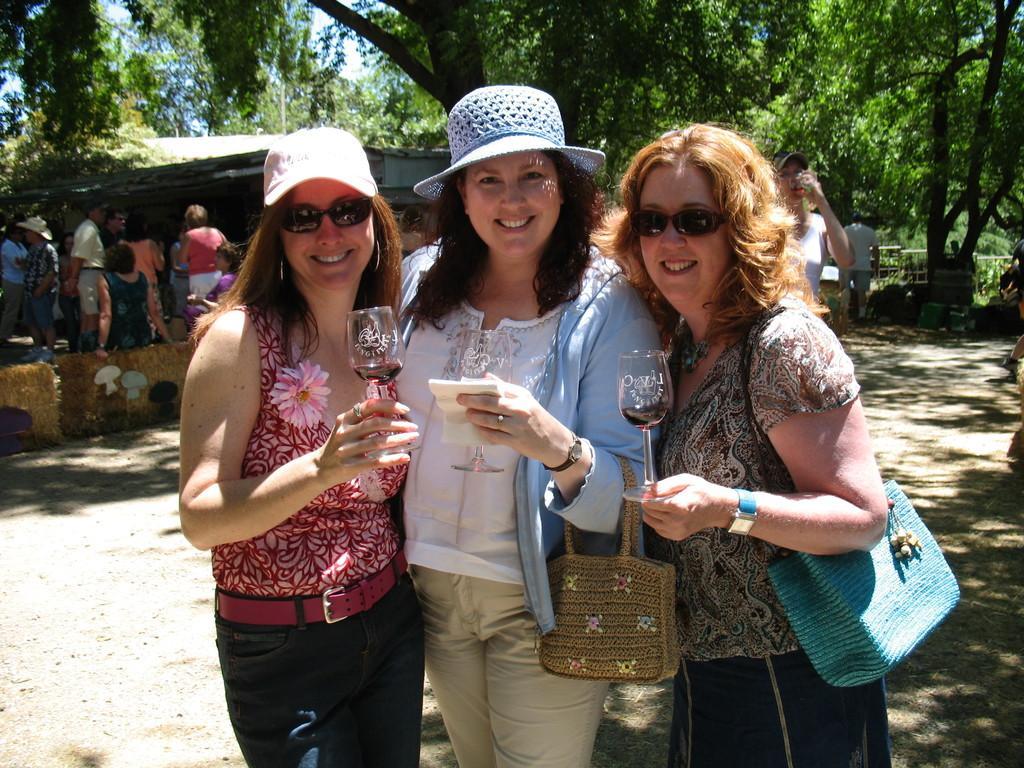Describe this image in one or two sentences. As we can see in the image there are few people here and there, trees, house and sky. The people in the front are holding glasses. 